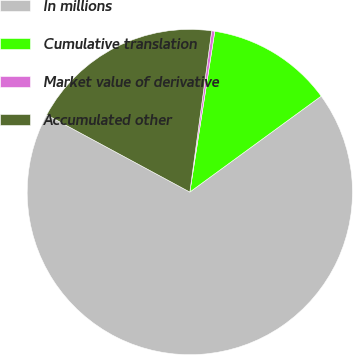<chart> <loc_0><loc_0><loc_500><loc_500><pie_chart><fcel>In millions<fcel>Cumulative translation<fcel>Market value of derivative<fcel>Accumulated other<nl><fcel>67.91%<fcel>12.51%<fcel>0.31%<fcel>19.27%<nl></chart> 